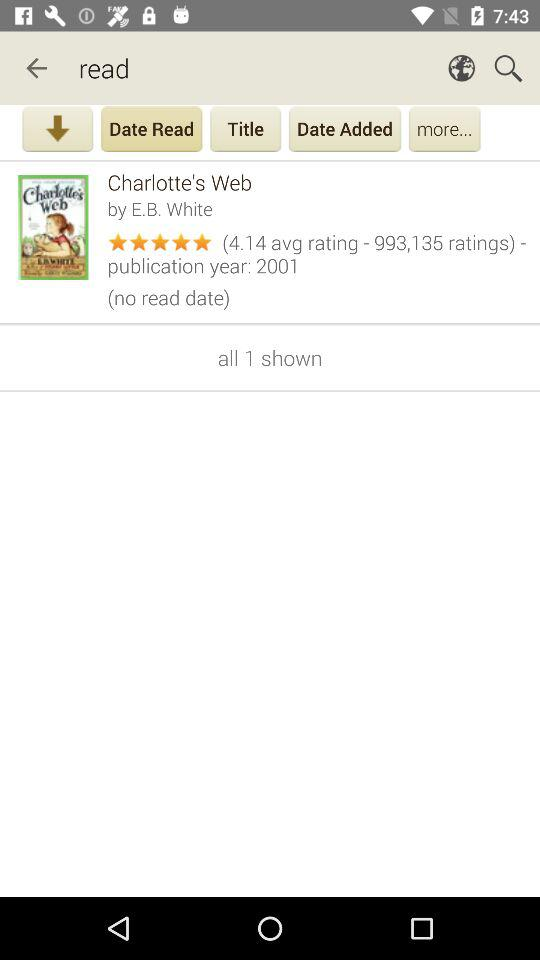What is the average rating of "Charlotte's Web"? The average rating is 4.14. 